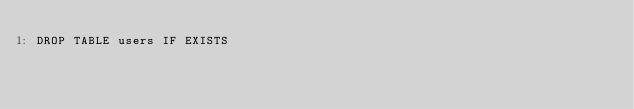<code> <loc_0><loc_0><loc_500><loc_500><_SQL_>DROP TABLE users IF EXISTS</code> 